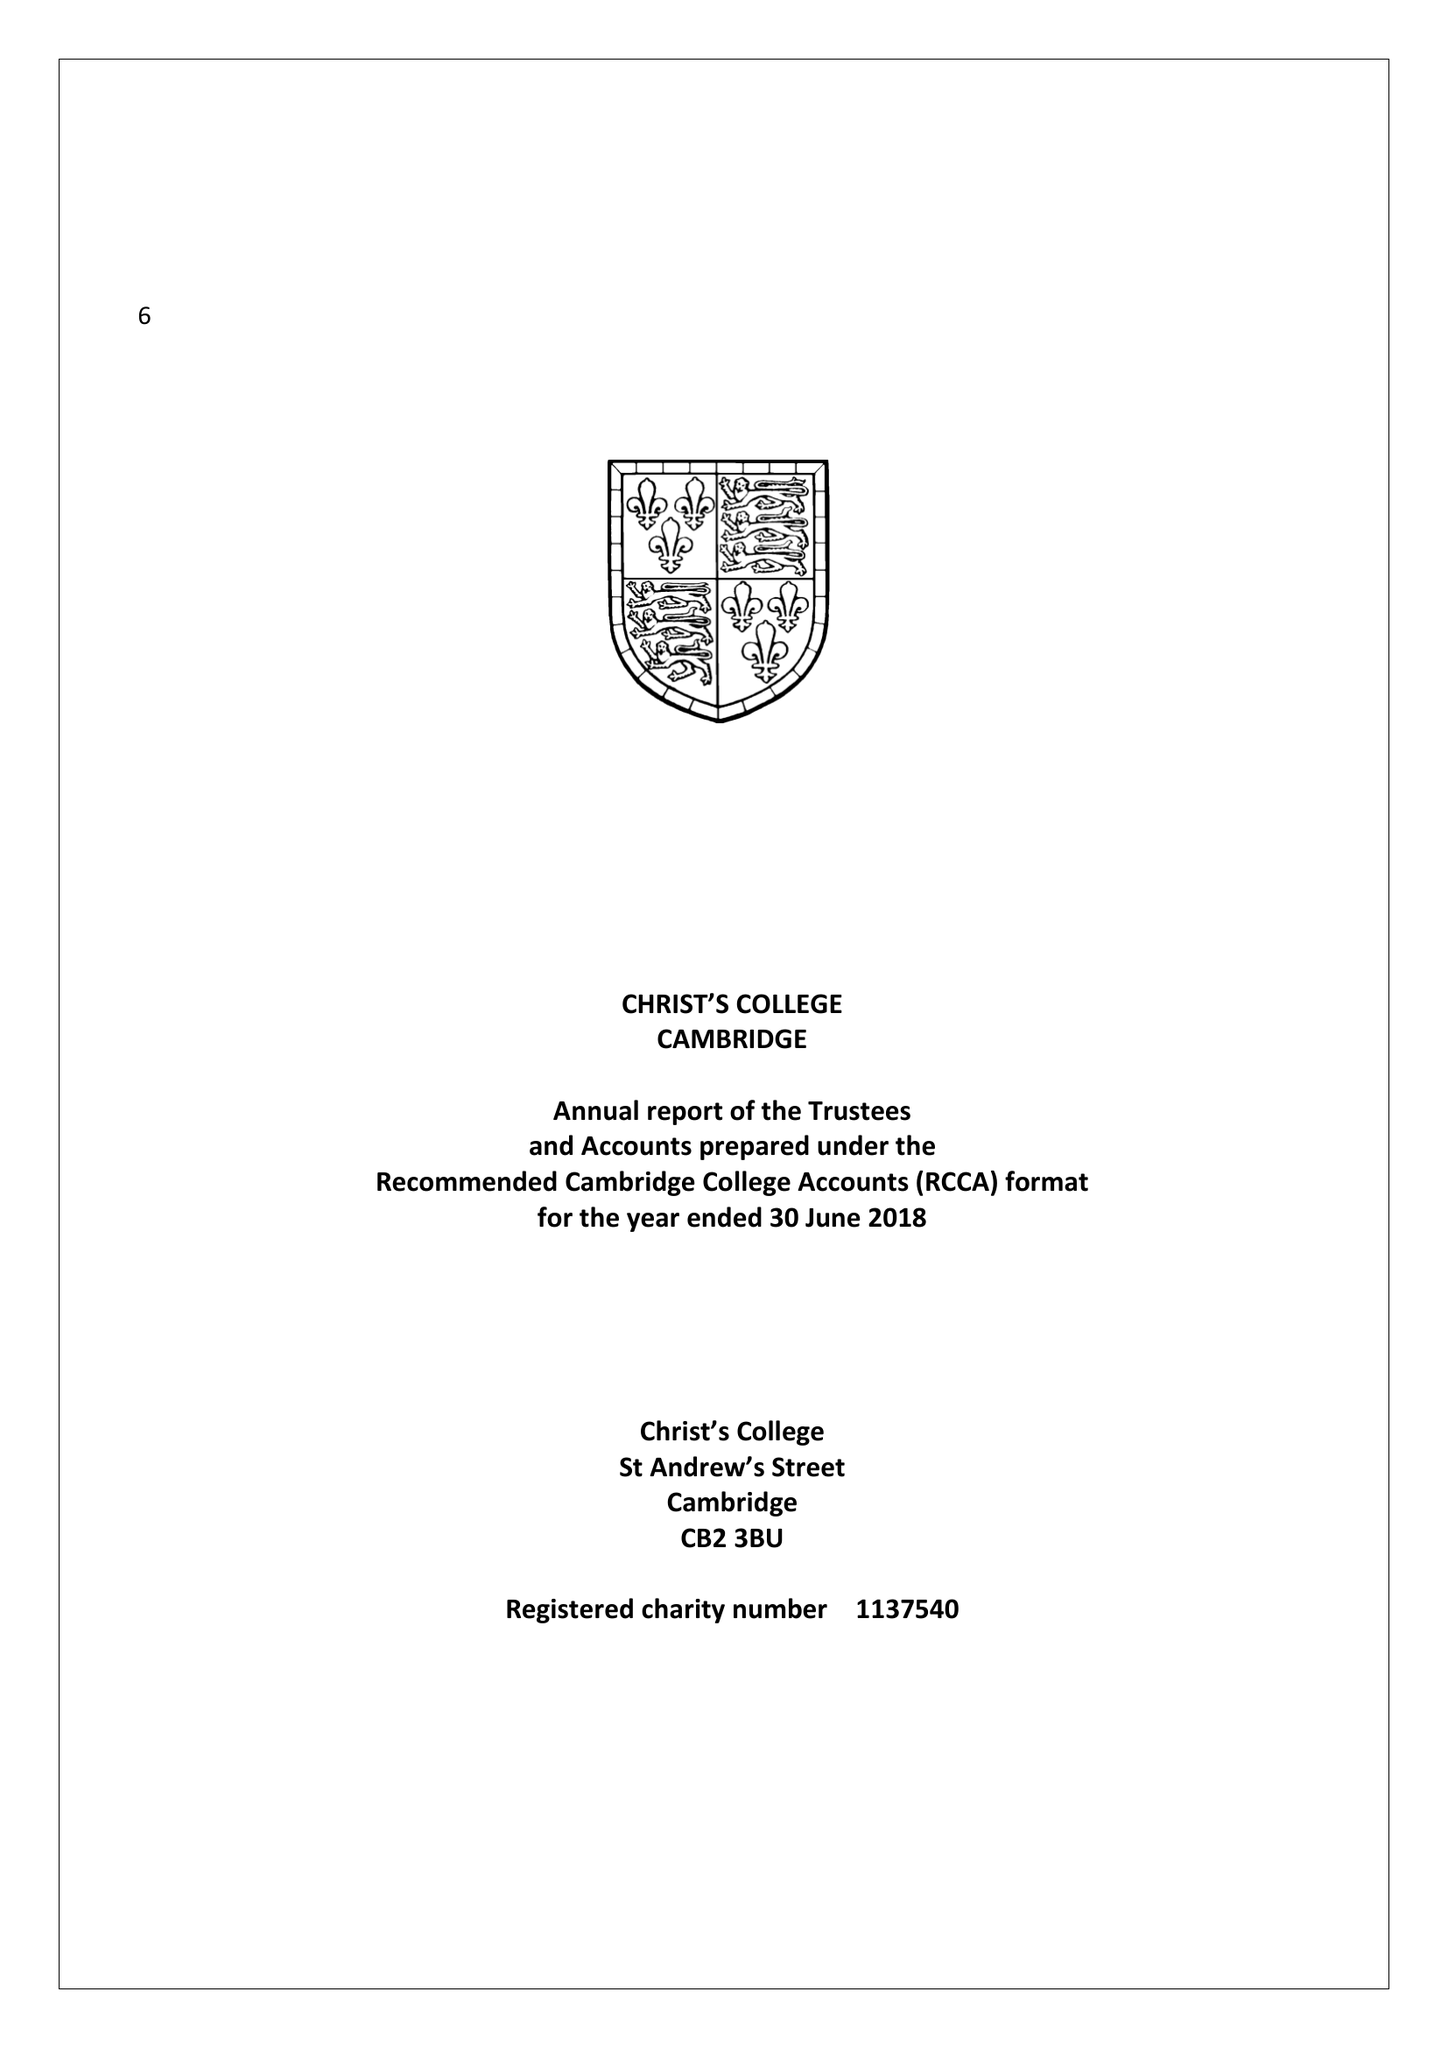What is the value for the address__street_line?
Answer the question using a single word or phrase. ST ANDREW'S STREET 